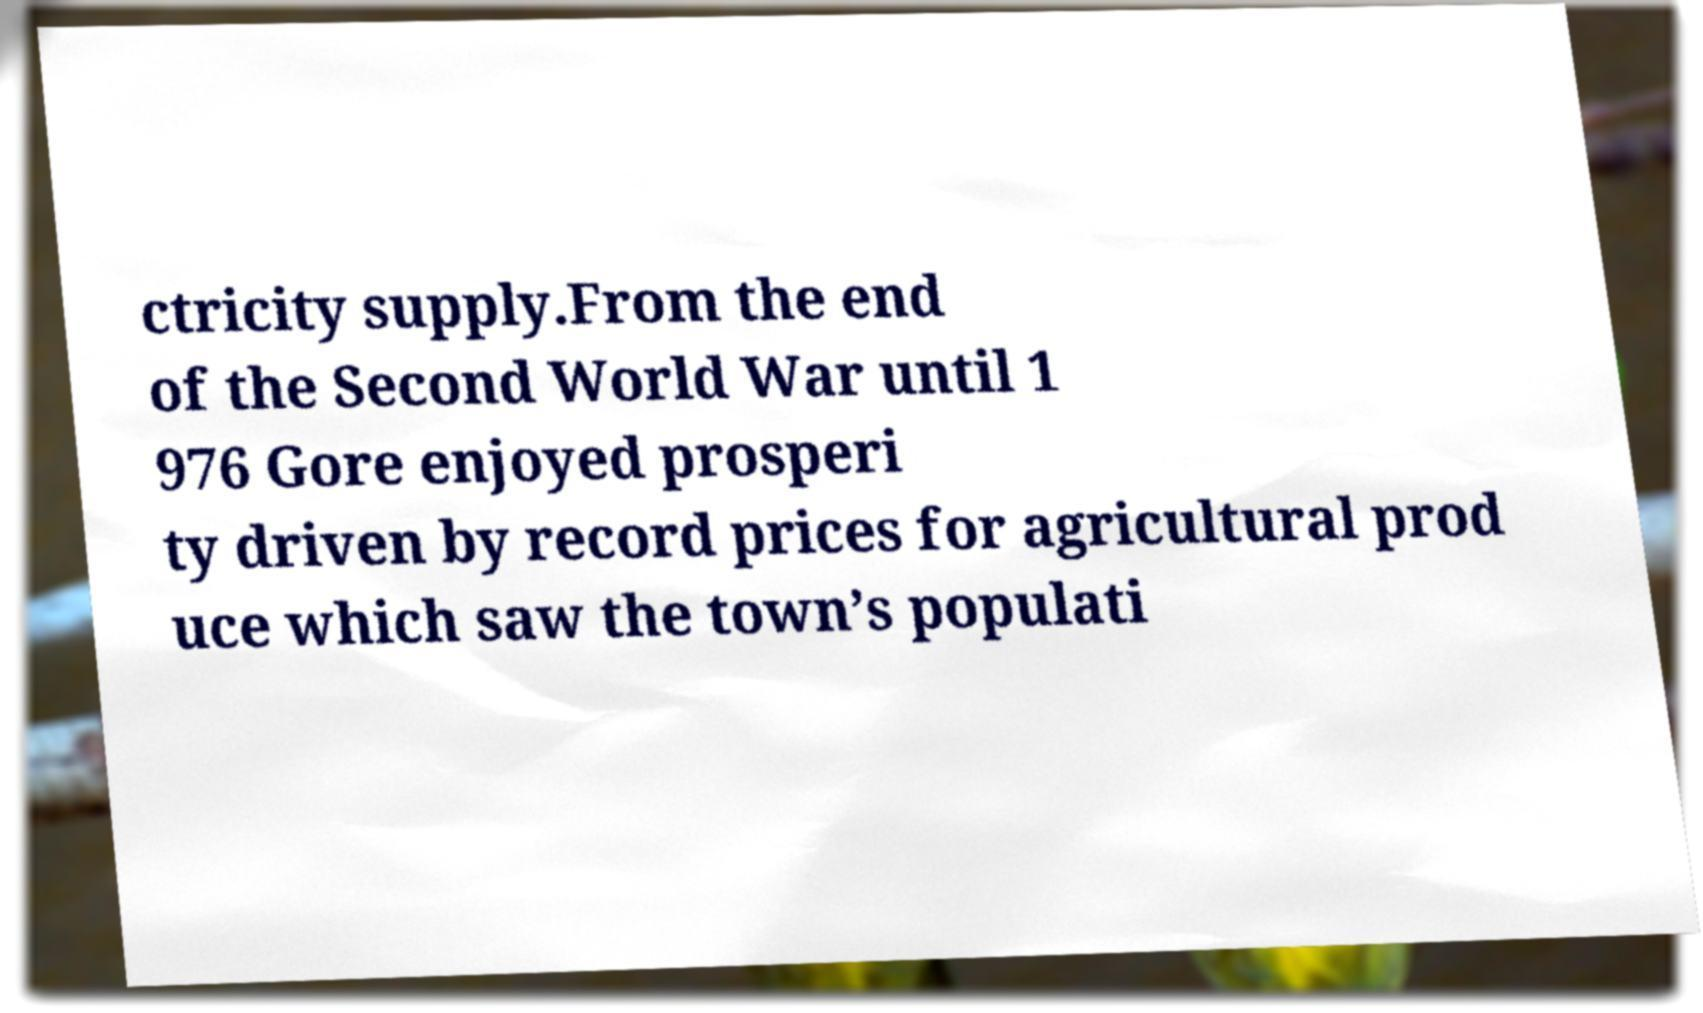What messages or text are displayed in this image? I need them in a readable, typed format. ctricity supply.From the end of the Second World War until 1 976 Gore enjoyed prosperi ty driven by record prices for agricultural prod uce which saw the town’s populati 